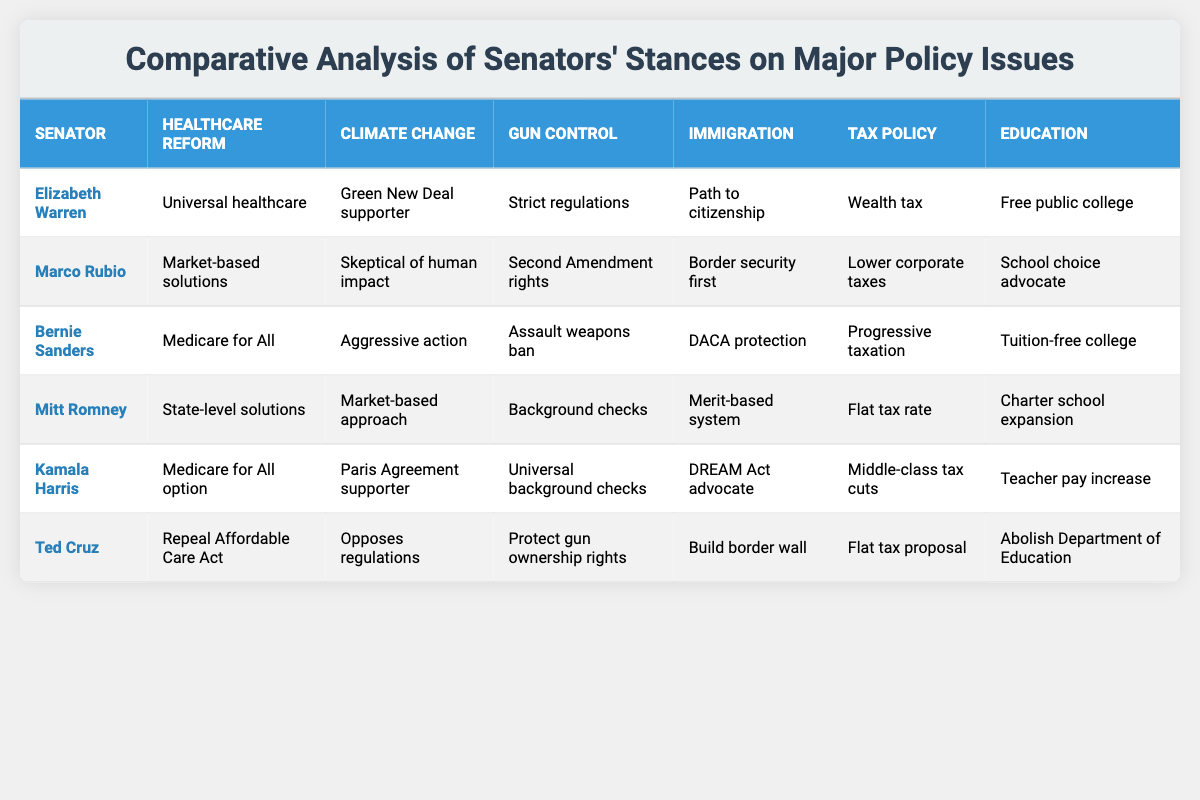What stance does Elizabeth Warren take on Gun Control? The table shows that Elizabeth Warren supports "Strict regulations" for Gun Control.
Answer: Strict regulations Which senator advocates for a "Market-based solutions" approach to Healthcare Reform? By looking at the Healthcare Reform column, Marco Rubio is the senator who supports "Market-based solutions."
Answer: Marco Rubio Which senators support a **Medicare for All** proposal? The table lists Bernie Sanders as advocating for "Medicare for All," and Kamala Harris supports a "Medicare for All option." Thus, the senators are Bernie Sanders and Kamala Harris.
Answer: Bernie Sanders and Kamala Harris Who among the senators is in favor of a flat tax proposal? The tax policy column indicates that Ted Cruz and Mitt Romney both have flat tax stances, with Ted Cruz supporting a "Flat tax proposal" and Mitt Romney supporting a "Flat tax rate."
Answer: Ted Cruz and Mitt Romney What is the common ground between Kamala Harris and Elizabeth Warren regarding Education? Both senators support educational reforms, with Kamala Harris advocating for "Teacher pay increase" and Elizabeth Warren proposing "Free public college." They differ in specifics but share a focus on enhancing education.
Answer: They both support educational reforms but differ in specifics Count the number of senators who support aggressive action on Climate Change. The table reveals that Bernie Sanders supports "Aggressive action," while Kamala Harris supports the "Paris Agreement." So, there are two senators with affirmative stances.
Answer: 2 Does Marco Rubio support strict immigration policies? Examining the immigration stance column, Marco Rubio emphasizes "Border security first," which can be interpreted as a strict policy approach.
Answer: Yes Which senator has the most progressive stance on Tax Policy? By comparing the Tax Policy attitudes, Bernie Sanders advocates for "Progressive taxation," while others like Ted Cruz and Mitt Romney offer flat tax options. Therefore, Bernie Sanders demonstrates the most progressive stance.
Answer: Bernie Sanders Is there a senator who opposes regulations related to Climate Change? Ted Cruz's stance "Opposes regulations" indicates he is against such measures, confirming there is a senator with this position.
Answer: Yes Which senator's position on Gun Control includes **Universal background checks**? The table clearly states that Kamala Harris advocates for "Universal background checks" regarding Gun Control.
Answer: Kamala Harris Which senator's overall policy stances are the most aligned with progressive ideals? Reviewing the stances on various topics, Elizabeth Warren and Bernie Sanders have strong progressive positions, but Bernie Sanders, particularly with "Medicare for All" and "Progressive taxation," leads in that regard.
Answer: Bernie Sanders 